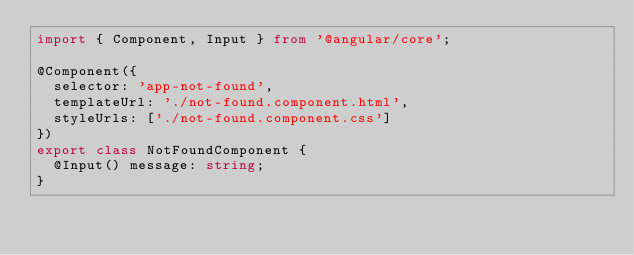<code> <loc_0><loc_0><loc_500><loc_500><_TypeScript_>import { Component, Input } from '@angular/core';

@Component({
  selector: 'app-not-found',
  templateUrl: './not-found.component.html',
  styleUrls: ['./not-found.component.css']
})
export class NotFoundComponent {
  @Input() message: string;
}
</code> 